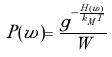Convert formula to latex. <formula><loc_0><loc_0><loc_500><loc_500>P ( w ) = \frac { g ^ { - \frac { H ( w ) } { k _ { M } T } } } { W }</formula> 